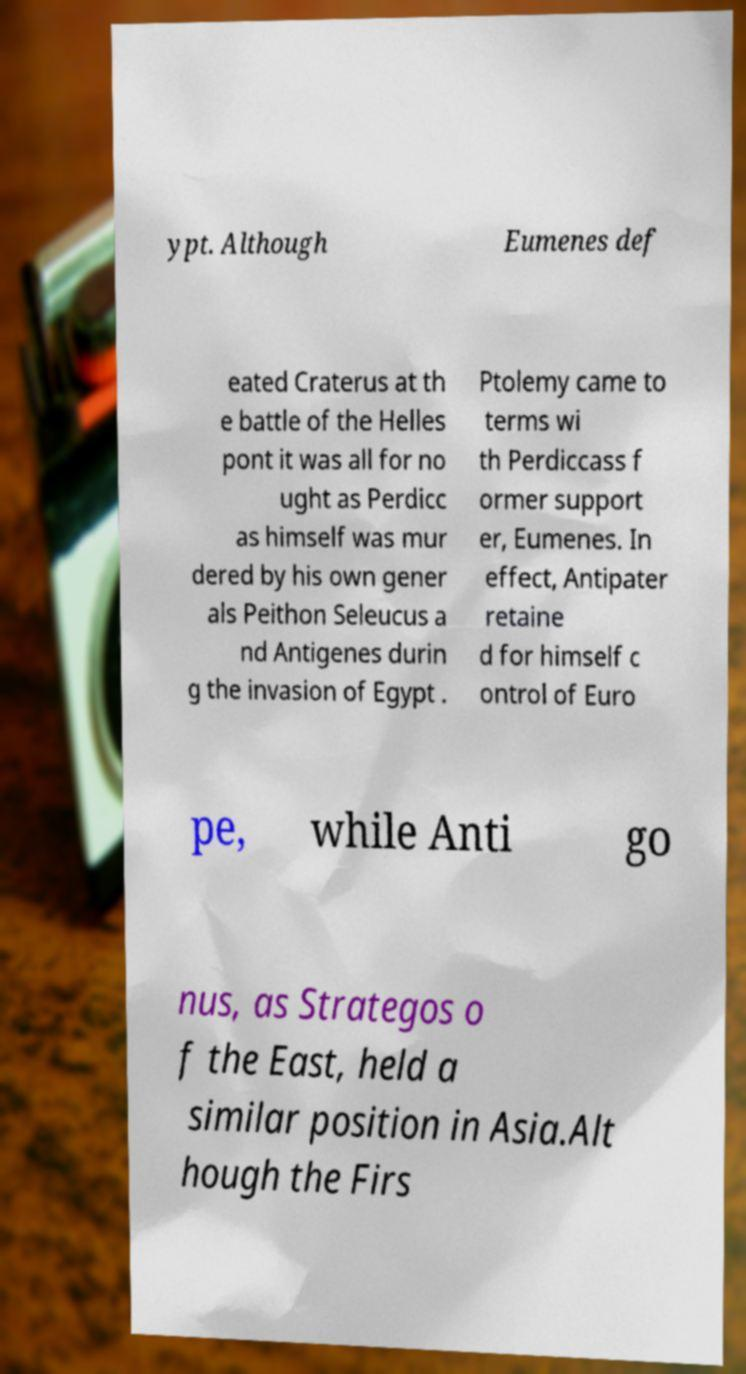Please read and relay the text visible in this image. What does it say? ypt. Although Eumenes def eated Craterus at th e battle of the Helles pont it was all for no ught as Perdicc as himself was mur dered by his own gener als Peithon Seleucus a nd Antigenes durin g the invasion of Egypt . Ptolemy came to terms wi th Perdiccass f ormer support er, Eumenes. In effect, Antipater retaine d for himself c ontrol of Euro pe, while Anti go nus, as Strategos o f the East, held a similar position in Asia.Alt hough the Firs 